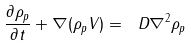<formula> <loc_0><loc_0><loc_500><loc_500>\frac { \partial { \rho _ { p } } } { \partial { t } } + \nabla ( \rho _ { p } V ) = \ D \nabla ^ { 2 } \rho _ { p }</formula> 